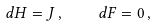Convert formula to latex. <formula><loc_0><loc_0><loc_500><loc_500>d H = J \, , \quad d F = 0 \, ,</formula> 